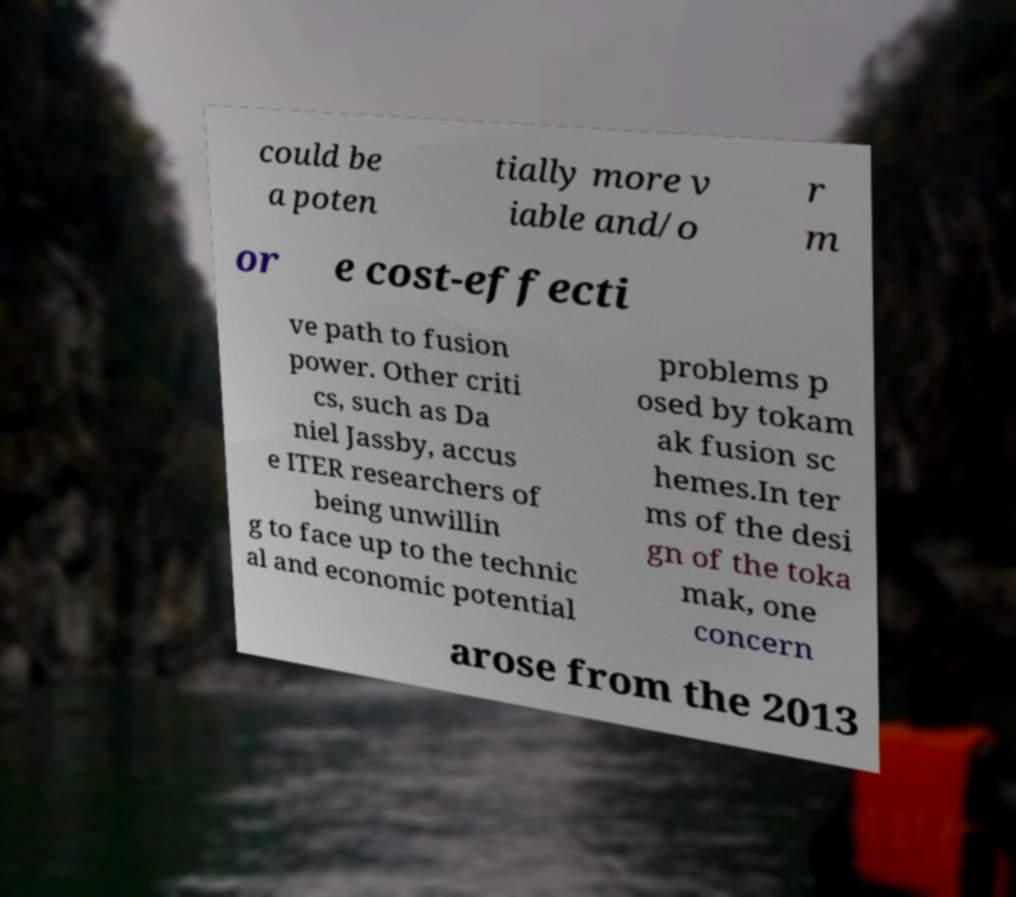There's text embedded in this image that I need extracted. Can you transcribe it verbatim? could be a poten tially more v iable and/o r m or e cost-effecti ve path to fusion power. Other criti cs, such as Da niel Jassby, accus e ITER researchers of being unwillin g to face up to the technic al and economic potential problems p osed by tokam ak fusion sc hemes.In ter ms of the desi gn of the toka mak, one concern arose from the 2013 